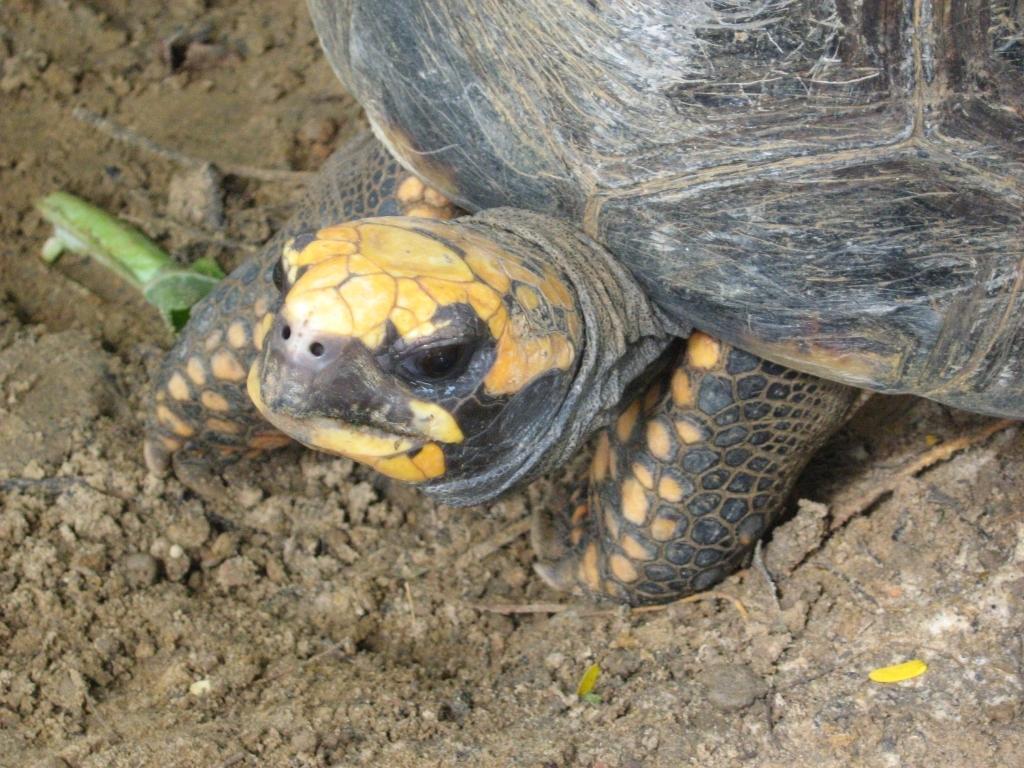Describe this image in one or two sentences. In this picture I can see a tortoise on the ground, it is black and light brown in color. 